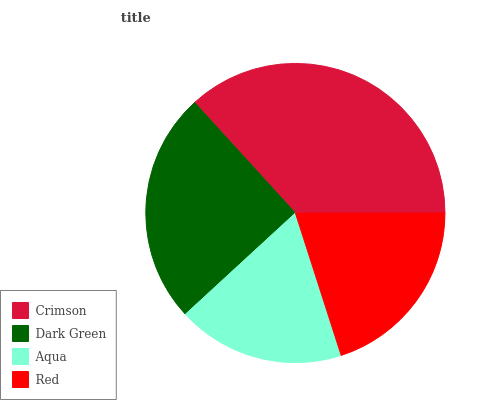Is Aqua the minimum?
Answer yes or no. Yes. Is Crimson the maximum?
Answer yes or no. Yes. Is Dark Green the minimum?
Answer yes or no. No. Is Dark Green the maximum?
Answer yes or no. No. Is Crimson greater than Dark Green?
Answer yes or no. Yes. Is Dark Green less than Crimson?
Answer yes or no. Yes. Is Dark Green greater than Crimson?
Answer yes or no. No. Is Crimson less than Dark Green?
Answer yes or no. No. Is Dark Green the high median?
Answer yes or no. Yes. Is Red the low median?
Answer yes or no. Yes. Is Aqua the high median?
Answer yes or no. No. Is Crimson the low median?
Answer yes or no. No. 